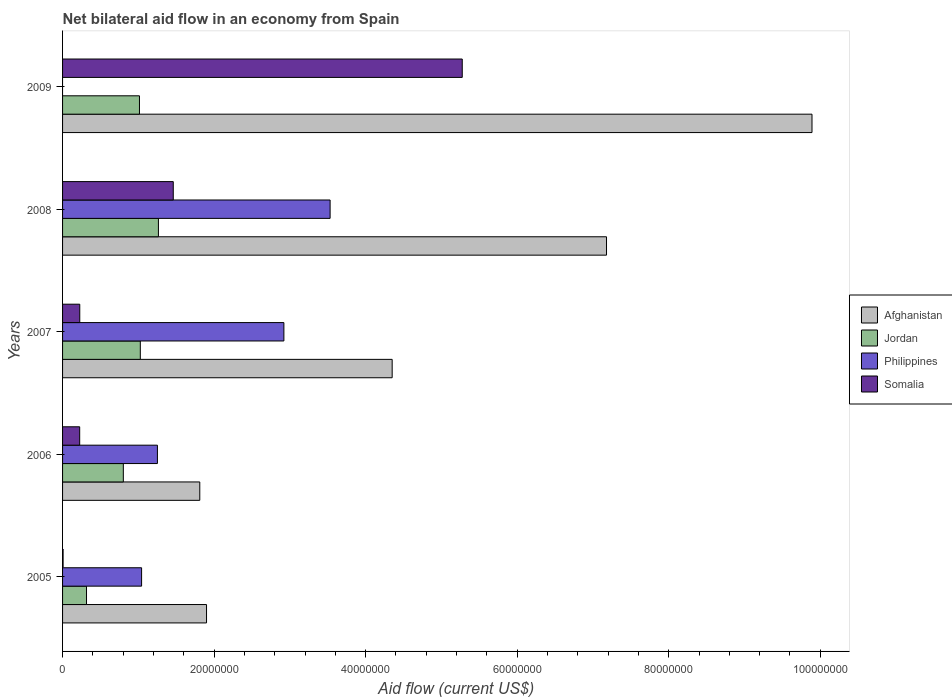Are the number of bars on each tick of the Y-axis equal?
Your response must be concise. No. What is the net bilateral aid flow in Jordan in 2006?
Provide a succinct answer. 8.02e+06. Across all years, what is the maximum net bilateral aid flow in Afghanistan?
Ensure brevity in your answer.  9.89e+07. In which year was the net bilateral aid flow in Philippines maximum?
Ensure brevity in your answer.  2008. What is the total net bilateral aid flow in Somalia in the graph?
Provide a short and direct response. 7.20e+07. What is the difference between the net bilateral aid flow in Somalia in 2006 and that in 2007?
Offer a terse response. -10000. What is the difference between the net bilateral aid flow in Afghanistan in 2009 and the net bilateral aid flow in Somalia in 2008?
Offer a very short reply. 8.43e+07. What is the average net bilateral aid flow in Jordan per year?
Your answer should be very brief. 8.85e+06. In the year 2006, what is the difference between the net bilateral aid flow in Jordan and net bilateral aid flow in Afghanistan?
Give a very brief answer. -1.01e+07. In how many years, is the net bilateral aid flow in Afghanistan greater than 24000000 US$?
Provide a short and direct response. 3. What is the ratio of the net bilateral aid flow in Somalia in 2005 to that in 2009?
Keep it short and to the point. 0. Is the net bilateral aid flow in Somalia in 2005 less than that in 2006?
Offer a very short reply. Yes. Is the difference between the net bilateral aid flow in Jordan in 2007 and 2008 greater than the difference between the net bilateral aid flow in Afghanistan in 2007 and 2008?
Your response must be concise. Yes. What is the difference between the highest and the second highest net bilateral aid flow in Jordan?
Keep it short and to the point. 2.39e+06. What is the difference between the highest and the lowest net bilateral aid flow in Somalia?
Your response must be concise. 5.27e+07. In how many years, is the net bilateral aid flow in Philippines greater than the average net bilateral aid flow in Philippines taken over all years?
Provide a succinct answer. 2. Is the sum of the net bilateral aid flow in Jordan in 2005 and 2007 greater than the maximum net bilateral aid flow in Afghanistan across all years?
Provide a short and direct response. No. Is it the case that in every year, the sum of the net bilateral aid flow in Jordan and net bilateral aid flow in Somalia is greater than the sum of net bilateral aid flow in Philippines and net bilateral aid flow in Afghanistan?
Give a very brief answer. No. How many years are there in the graph?
Keep it short and to the point. 5. What is the difference between two consecutive major ticks on the X-axis?
Make the answer very short. 2.00e+07. Are the values on the major ticks of X-axis written in scientific E-notation?
Offer a very short reply. No. Where does the legend appear in the graph?
Offer a terse response. Center right. How many legend labels are there?
Offer a terse response. 4. How are the legend labels stacked?
Provide a succinct answer. Vertical. What is the title of the graph?
Make the answer very short. Net bilateral aid flow in an economy from Spain. Does "Switzerland" appear as one of the legend labels in the graph?
Keep it short and to the point. No. What is the Aid flow (current US$) of Afghanistan in 2005?
Give a very brief answer. 1.90e+07. What is the Aid flow (current US$) in Jordan in 2005?
Ensure brevity in your answer.  3.16e+06. What is the Aid flow (current US$) in Philippines in 2005?
Your response must be concise. 1.04e+07. What is the Aid flow (current US$) in Somalia in 2005?
Your answer should be compact. 7.00e+04. What is the Aid flow (current US$) of Afghanistan in 2006?
Offer a very short reply. 1.81e+07. What is the Aid flow (current US$) in Jordan in 2006?
Your answer should be compact. 8.02e+06. What is the Aid flow (current US$) in Philippines in 2006?
Ensure brevity in your answer.  1.25e+07. What is the Aid flow (current US$) of Somalia in 2006?
Your answer should be compact. 2.26e+06. What is the Aid flow (current US$) in Afghanistan in 2007?
Offer a very short reply. 4.35e+07. What is the Aid flow (current US$) in Jordan in 2007?
Ensure brevity in your answer.  1.03e+07. What is the Aid flow (current US$) of Philippines in 2007?
Offer a very short reply. 2.92e+07. What is the Aid flow (current US$) of Somalia in 2007?
Provide a short and direct response. 2.27e+06. What is the Aid flow (current US$) of Afghanistan in 2008?
Provide a short and direct response. 7.18e+07. What is the Aid flow (current US$) in Jordan in 2008?
Your answer should be compact. 1.26e+07. What is the Aid flow (current US$) in Philippines in 2008?
Ensure brevity in your answer.  3.53e+07. What is the Aid flow (current US$) of Somalia in 2008?
Provide a short and direct response. 1.46e+07. What is the Aid flow (current US$) of Afghanistan in 2009?
Keep it short and to the point. 9.89e+07. What is the Aid flow (current US$) in Jordan in 2009?
Your response must be concise. 1.02e+07. What is the Aid flow (current US$) of Somalia in 2009?
Your response must be concise. 5.28e+07. Across all years, what is the maximum Aid flow (current US$) of Afghanistan?
Ensure brevity in your answer.  9.89e+07. Across all years, what is the maximum Aid flow (current US$) of Jordan?
Keep it short and to the point. 1.26e+07. Across all years, what is the maximum Aid flow (current US$) in Philippines?
Offer a very short reply. 3.53e+07. Across all years, what is the maximum Aid flow (current US$) in Somalia?
Make the answer very short. 5.28e+07. Across all years, what is the minimum Aid flow (current US$) of Afghanistan?
Offer a very short reply. 1.81e+07. Across all years, what is the minimum Aid flow (current US$) of Jordan?
Your response must be concise. 3.16e+06. What is the total Aid flow (current US$) of Afghanistan in the graph?
Your answer should be compact. 2.51e+08. What is the total Aid flow (current US$) in Jordan in the graph?
Provide a short and direct response. 4.42e+07. What is the total Aid flow (current US$) in Philippines in the graph?
Keep it short and to the point. 8.75e+07. What is the total Aid flow (current US$) in Somalia in the graph?
Give a very brief answer. 7.20e+07. What is the difference between the Aid flow (current US$) in Afghanistan in 2005 and that in 2006?
Provide a succinct answer. 8.90e+05. What is the difference between the Aid flow (current US$) in Jordan in 2005 and that in 2006?
Your response must be concise. -4.86e+06. What is the difference between the Aid flow (current US$) in Philippines in 2005 and that in 2006?
Your answer should be very brief. -2.09e+06. What is the difference between the Aid flow (current US$) of Somalia in 2005 and that in 2006?
Ensure brevity in your answer.  -2.19e+06. What is the difference between the Aid flow (current US$) in Afghanistan in 2005 and that in 2007?
Your answer should be very brief. -2.45e+07. What is the difference between the Aid flow (current US$) of Jordan in 2005 and that in 2007?
Your response must be concise. -7.10e+06. What is the difference between the Aid flow (current US$) in Philippines in 2005 and that in 2007?
Offer a very short reply. -1.88e+07. What is the difference between the Aid flow (current US$) of Somalia in 2005 and that in 2007?
Offer a terse response. -2.20e+06. What is the difference between the Aid flow (current US$) in Afghanistan in 2005 and that in 2008?
Give a very brief answer. -5.28e+07. What is the difference between the Aid flow (current US$) of Jordan in 2005 and that in 2008?
Provide a succinct answer. -9.49e+06. What is the difference between the Aid flow (current US$) in Philippines in 2005 and that in 2008?
Keep it short and to the point. -2.49e+07. What is the difference between the Aid flow (current US$) in Somalia in 2005 and that in 2008?
Your answer should be very brief. -1.45e+07. What is the difference between the Aid flow (current US$) in Afghanistan in 2005 and that in 2009?
Provide a short and direct response. -7.99e+07. What is the difference between the Aid flow (current US$) of Jordan in 2005 and that in 2009?
Your answer should be very brief. -6.99e+06. What is the difference between the Aid flow (current US$) of Somalia in 2005 and that in 2009?
Keep it short and to the point. -5.27e+07. What is the difference between the Aid flow (current US$) in Afghanistan in 2006 and that in 2007?
Offer a terse response. -2.54e+07. What is the difference between the Aid flow (current US$) of Jordan in 2006 and that in 2007?
Your response must be concise. -2.24e+06. What is the difference between the Aid flow (current US$) of Philippines in 2006 and that in 2007?
Keep it short and to the point. -1.67e+07. What is the difference between the Aid flow (current US$) in Somalia in 2006 and that in 2007?
Your answer should be very brief. -10000. What is the difference between the Aid flow (current US$) of Afghanistan in 2006 and that in 2008?
Your answer should be compact. -5.37e+07. What is the difference between the Aid flow (current US$) in Jordan in 2006 and that in 2008?
Provide a succinct answer. -4.63e+06. What is the difference between the Aid flow (current US$) in Philippines in 2006 and that in 2008?
Provide a short and direct response. -2.28e+07. What is the difference between the Aid flow (current US$) of Somalia in 2006 and that in 2008?
Offer a very short reply. -1.24e+07. What is the difference between the Aid flow (current US$) of Afghanistan in 2006 and that in 2009?
Offer a terse response. -8.08e+07. What is the difference between the Aid flow (current US$) of Jordan in 2006 and that in 2009?
Provide a short and direct response. -2.13e+06. What is the difference between the Aid flow (current US$) in Somalia in 2006 and that in 2009?
Give a very brief answer. -5.05e+07. What is the difference between the Aid flow (current US$) of Afghanistan in 2007 and that in 2008?
Your response must be concise. -2.83e+07. What is the difference between the Aid flow (current US$) in Jordan in 2007 and that in 2008?
Offer a very short reply. -2.39e+06. What is the difference between the Aid flow (current US$) of Philippines in 2007 and that in 2008?
Offer a terse response. -6.10e+06. What is the difference between the Aid flow (current US$) of Somalia in 2007 and that in 2008?
Give a very brief answer. -1.23e+07. What is the difference between the Aid flow (current US$) of Afghanistan in 2007 and that in 2009?
Your answer should be very brief. -5.54e+07. What is the difference between the Aid flow (current US$) in Jordan in 2007 and that in 2009?
Ensure brevity in your answer.  1.10e+05. What is the difference between the Aid flow (current US$) in Somalia in 2007 and that in 2009?
Your response must be concise. -5.05e+07. What is the difference between the Aid flow (current US$) of Afghanistan in 2008 and that in 2009?
Provide a succinct answer. -2.71e+07. What is the difference between the Aid flow (current US$) in Jordan in 2008 and that in 2009?
Provide a short and direct response. 2.50e+06. What is the difference between the Aid flow (current US$) in Somalia in 2008 and that in 2009?
Your response must be concise. -3.81e+07. What is the difference between the Aid flow (current US$) of Afghanistan in 2005 and the Aid flow (current US$) of Jordan in 2006?
Offer a very short reply. 1.10e+07. What is the difference between the Aid flow (current US$) in Afghanistan in 2005 and the Aid flow (current US$) in Philippines in 2006?
Your answer should be compact. 6.48e+06. What is the difference between the Aid flow (current US$) in Afghanistan in 2005 and the Aid flow (current US$) in Somalia in 2006?
Offer a terse response. 1.67e+07. What is the difference between the Aid flow (current US$) of Jordan in 2005 and the Aid flow (current US$) of Philippines in 2006?
Provide a succinct answer. -9.36e+06. What is the difference between the Aid flow (current US$) in Philippines in 2005 and the Aid flow (current US$) in Somalia in 2006?
Provide a short and direct response. 8.17e+06. What is the difference between the Aid flow (current US$) in Afghanistan in 2005 and the Aid flow (current US$) in Jordan in 2007?
Your answer should be very brief. 8.74e+06. What is the difference between the Aid flow (current US$) of Afghanistan in 2005 and the Aid flow (current US$) of Philippines in 2007?
Ensure brevity in your answer.  -1.02e+07. What is the difference between the Aid flow (current US$) in Afghanistan in 2005 and the Aid flow (current US$) in Somalia in 2007?
Keep it short and to the point. 1.67e+07. What is the difference between the Aid flow (current US$) in Jordan in 2005 and the Aid flow (current US$) in Philippines in 2007?
Your answer should be very brief. -2.60e+07. What is the difference between the Aid flow (current US$) in Jordan in 2005 and the Aid flow (current US$) in Somalia in 2007?
Make the answer very short. 8.90e+05. What is the difference between the Aid flow (current US$) in Philippines in 2005 and the Aid flow (current US$) in Somalia in 2007?
Your answer should be very brief. 8.16e+06. What is the difference between the Aid flow (current US$) of Afghanistan in 2005 and the Aid flow (current US$) of Jordan in 2008?
Your response must be concise. 6.35e+06. What is the difference between the Aid flow (current US$) of Afghanistan in 2005 and the Aid flow (current US$) of Philippines in 2008?
Give a very brief answer. -1.63e+07. What is the difference between the Aid flow (current US$) of Afghanistan in 2005 and the Aid flow (current US$) of Somalia in 2008?
Keep it short and to the point. 4.39e+06. What is the difference between the Aid flow (current US$) of Jordan in 2005 and the Aid flow (current US$) of Philippines in 2008?
Your response must be concise. -3.22e+07. What is the difference between the Aid flow (current US$) in Jordan in 2005 and the Aid flow (current US$) in Somalia in 2008?
Ensure brevity in your answer.  -1.14e+07. What is the difference between the Aid flow (current US$) of Philippines in 2005 and the Aid flow (current US$) of Somalia in 2008?
Your response must be concise. -4.18e+06. What is the difference between the Aid flow (current US$) in Afghanistan in 2005 and the Aid flow (current US$) in Jordan in 2009?
Your answer should be compact. 8.85e+06. What is the difference between the Aid flow (current US$) of Afghanistan in 2005 and the Aid flow (current US$) of Somalia in 2009?
Your answer should be very brief. -3.38e+07. What is the difference between the Aid flow (current US$) in Jordan in 2005 and the Aid flow (current US$) in Somalia in 2009?
Your answer should be compact. -4.96e+07. What is the difference between the Aid flow (current US$) in Philippines in 2005 and the Aid flow (current US$) in Somalia in 2009?
Provide a short and direct response. -4.23e+07. What is the difference between the Aid flow (current US$) of Afghanistan in 2006 and the Aid flow (current US$) of Jordan in 2007?
Provide a succinct answer. 7.85e+06. What is the difference between the Aid flow (current US$) of Afghanistan in 2006 and the Aid flow (current US$) of Philippines in 2007?
Provide a succinct answer. -1.11e+07. What is the difference between the Aid flow (current US$) in Afghanistan in 2006 and the Aid flow (current US$) in Somalia in 2007?
Make the answer very short. 1.58e+07. What is the difference between the Aid flow (current US$) of Jordan in 2006 and the Aid flow (current US$) of Philippines in 2007?
Offer a very short reply. -2.12e+07. What is the difference between the Aid flow (current US$) in Jordan in 2006 and the Aid flow (current US$) in Somalia in 2007?
Your answer should be compact. 5.75e+06. What is the difference between the Aid flow (current US$) of Philippines in 2006 and the Aid flow (current US$) of Somalia in 2007?
Provide a short and direct response. 1.02e+07. What is the difference between the Aid flow (current US$) of Afghanistan in 2006 and the Aid flow (current US$) of Jordan in 2008?
Ensure brevity in your answer.  5.46e+06. What is the difference between the Aid flow (current US$) in Afghanistan in 2006 and the Aid flow (current US$) in Philippines in 2008?
Offer a terse response. -1.72e+07. What is the difference between the Aid flow (current US$) of Afghanistan in 2006 and the Aid flow (current US$) of Somalia in 2008?
Your answer should be compact. 3.50e+06. What is the difference between the Aid flow (current US$) of Jordan in 2006 and the Aid flow (current US$) of Philippines in 2008?
Offer a very short reply. -2.73e+07. What is the difference between the Aid flow (current US$) of Jordan in 2006 and the Aid flow (current US$) of Somalia in 2008?
Provide a succinct answer. -6.59e+06. What is the difference between the Aid flow (current US$) in Philippines in 2006 and the Aid flow (current US$) in Somalia in 2008?
Your answer should be very brief. -2.09e+06. What is the difference between the Aid flow (current US$) in Afghanistan in 2006 and the Aid flow (current US$) in Jordan in 2009?
Provide a succinct answer. 7.96e+06. What is the difference between the Aid flow (current US$) in Afghanistan in 2006 and the Aid flow (current US$) in Somalia in 2009?
Make the answer very short. -3.46e+07. What is the difference between the Aid flow (current US$) in Jordan in 2006 and the Aid flow (current US$) in Somalia in 2009?
Your response must be concise. -4.47e+07. What is the difference between the Aid flow (current US$) of Philippines in 2006 and the Aid flow (current US$) of Somalia in 2009?
Make the answer very short. -4.02e+07. What is the difference between the Aid flow (current US$) in Afghanistan in 2007 and the Aid flow (current US$) in Jordan in 2008?
Provide a short and direct response. 3.08e+07. What is the difference between the Aid flow (current US$) in Afghanistan in 2007 and the Aid flow (current US$) in Philippines in 2008?
Offer a terse response. 8.19e+06. What is the difference between the Aid flow (current US$) in Afghanistan in 2007 and the Aid flow (current US$) in Somalia in 2008?
Your answer should be compact. 2.89e+07. What is the difference between the Aid flow (current US$) of Jordan in 2007 and the Aid flow (current US$) of Philippines in 2008?
Keep it short and to the point. -2.50e+07. What is the difference between the Aid flow (current US$) of Jordan in 2007 and the Aid flow (current US$) of Somalia in 2008?
Offer a terse response. -4.35e+06. What is the difference between the Aid flow (current US$) of Philippines in 2007 and the Aid flow (current US$) of Somalia in 2008?
Make the answer very short. 1.46e+07. What is the difference between the Aid flow (current US$) in Afghanistan in 2007 and the Aid flow (current US$) in Jordan in 2009?
Make the answer very short. 3.34e+07. What is the difference between the Aid flow (current US$) in Afghanistan in 2007 and the Aid flow (current US$) in Somalia in 2009?
Your answer should be very brief. -9.25e+06. What is the difference between the Aid flow (current US$) in Jordan in 2007 and the Aid flow (current US$) in Somalia in 2009?
Your answer should be very brief. -4.25e+07. What is the difference between the Aid flow (current US$) of Philippines in 2007 and the Aid flow (current US$) of Somalia in 2009?
Ensure brevity in your answer.  -2.35e+07. What is the difference between the Aid flow (current US$) of Afghanistan in 2008 and the Aid flow (current US$) of Jordan in 2009?
Offer a very short reply. 6.16e+07. What is the difference between the Aid flow (current US$) in Afghanistan in 2008 and the Aid flow (current US$) in Somalia in 2009?
Make the answer very short. 1.90e+07. What is the difference between the Aid flow (current US$) in Jordan in 2008 and the Aid flow (current US$) in Somalia in 2009?
Make the answer very short. -4.01e+07. What is the difference between the Aid flow (current US$) of Philippines in 2008 and the Aid flow (current US$) of Somalia in 2009?
Your answer should be compact. -1.74e+07. What is the average Aid flow (current US$) of Afghanistan per year?
Your answer should be very brief. 5.03e+07. What is the average Aid flow (current US$) in Jordan per year?
Your answer should be very brief. 8.85e+06. What is the average Aid flow (current US$) of Philippines per year?
Keep it short and to the point. 1.75e+07. What is the average Aid flow (current US$) in Somalia per year?
Your answer should be compact. 1.44e+07. In the year 2005, what is the difference between the Aid flow (current US$) of Afghanistan and Aid flow (current US$) of Jordan?
Keep it short and to the point. 1.58e+07. In the year 2005, what is the difference between the Aid flow (current US$) in Afghanistan and Aid flow (current US$) in Philippines?
Offer a very short reply. 8.57e+06. In the year 2005, what is the difference between the Aid flow (current US$) of Afghanistan and Aid flow (current US$) of Somalia?
Provide a short and direct response. 1.89e+07. In the year 2005, what is the difference between the Aid flow (current US$) of Jordan and Aid flow (current US$) of Philippines?
Your response must be concise. -7.27e+06. In the year 2005, what is the difference between the Aid flow (current US$) in Jordan and Aid flow (current US$) in Somalia?
Ensure brevity in your answer.  3.09e+06. In the year 2005, what is the difference between the Aid flow (current US$) of Philippines and Aid flow (current US$) of Somalia?
Offer a terse response. 1.04e+07. In the year 2006, what is the difference between the Aid flow (current US$) in Afghanistan and Aid flow (current US$) in Jordan?
Your answer should be very brief. 1.01e+07. In the year 2006, what is the difference between the Aid flow (current US$) of Afghanistan and Aid flow (current US$) of Philippines?
Ensure brevity in your answer.  5.59e+06. In the year 2006, what is the difference between the Aid flow (current US$) of Afghanistan and Aid flow (current US$) of Somalia?
Ensure brevity in your answer.  1.58e+07. In the year 2006, what is the difference between the Aid flow (current US$) of Jordan and Aid flow (current US$) of Philippines?
Your answer should be compact. -4.50e+06. In the year 2006, what is the difference between the Aid flow (current US$) of Jordan and Aid flow (current US$) of Somalia?
Make the answer very short. 5.76e+06. In the year 2006, what is the difference between the Aid flow (current US$) in Philippines and Aid flow (current US$) in Somalia?
Make the answer very short. 1.03e+07. In the year 2007, what is the difference between the Aid flow (current US$) of Afghanistan and Aid flow (current US$) of Jordan?
Make the answer very short. 3.32e+07. In the year 2007, what is the difference between the Aid flow (current US$) in Afghanistan and Aid flow (current US$) in Philippines?
Your response must be concise. 1.43e+07. In the year 2007, what is the difference between the Aid flow (current US$) of Afghanistan and Aid flow (current US$) of Somalia?
Your answer should be compact. 4.12e+07. In the year 2007, what is the difference between the Aid flow (current US$) in Jordan and Aid flow (current US$) in Philippines?
Ensure brevity in your answer.  -1.90e+07. In the year 2007, what is the difference between the Aid flow (current US$) in Jordan and Aid flow (current US$) in Somalia?
Your answer should be very brief. 7.99e+06. In the year 2007, what is the difference between the Aid flow (current US$) of Philippines and Aid flow (current US$) of Somalia?
Make the answer very short. 2.69e+07. In the year 2008, what is the difference between the Aid flow (current US$) of Afghanistan and Aid flow (current US$) of Jordan?
Provide a succinct answer. 5.91e+07. In the year 2008, what is the difference between the Aid flow (current US$) of Afghanistan and Aid flow (current US$) of Philippines?
Ensure brevity in your answer.  3.65e+07. In the year 2008, what is the difference between the Aid flow (current US$) of Afghanistan and Aid flow (current US$) of Somalia?
Your answer should be compact. 5.72e+07. In the year 2008, what is the difference between the Aid flow (current US$) in Jordan and Aid flow (current US$) in Philippines?
Offer a very short reply. -2.27e+07. In the year 2008, what is the difference between the Aid flow (current US$) of Jordan and Aid flow (current US$) of Somalia?
Offer a terse response. -1.96e+06. In the year 2008, what is the difference between the Aid flow (current US$) of Philippines and Aid flow (current US$) of Somalia?
Give a very brief answer. 2.07e+07. In the year 2009, what is the difference between the Aid flow (current US$) in Afghanistan and Aid flow (current US$) in Jordan?
Ensure brevity in your answer.  8.88e+07. In the year 2009, what is the difference between the Aid flow (current US$) in Afghanistan and Aid flow (current US$) in Somalia?
Your response must be concise. 4.62e+07. In the year 2009, what is the difference between the Aid flow (current US$) in Jordan and Aid flow (current US$) in Somalia?
Keep it short and to the point. -4.26e+07. What is the ratio of the Aid flow (current US$) of Afghanistan in 2005 to that in 2006?
Your answer should be very brief. 1.05. What is the ratio of the Aid flow (current US$) in Jordan in 2005 to that in 2006?
Your answer should be compact. 0.39. What is the ratio of the Aid flow (current US$) in Philippines in 2005 to that in 2006?
Provide a succinct answer. 0.83. What is the ratio of the Aid flow (current US$) in Somalia in 2005 to that in 2006?
Your answer should be very brief. 0.03. What is the ratio of the Aid flow (current US$) of Afghanistan in 2005 to that in 2007?
Offer a very short reply. 0.44. What is the ratio of the Aid flow (current US$) in Jordan in 2005 to that in 2007?
Provide a short and direct response. 0.31. What is the ratio of the Aid flow (current US$) of Philippines in 2005 to that in 2007?
Offer a terse response. 0.36. What is the ratio of the Aid flow (current US$) in Somalia in 2005 to that in 2007?
Keep it short and to the point. 0.03. What is the ratio of the Aid flow (current US$) in Afghanistan in 2005 to that in 2008?
Offer a very short reply. 0.26. What is the ratio of the Aid flow (current US$) of Jordan in 2005 to that in 2008?
Your answer should be compact. 0.25. What is the ratio of the Aid flow (current US$) of Philippines in 2005 to that in 2008?
Keep it short and to the point. 0.3. What is the ratio of the Aid flow (current US$) in Somalia in 2005 to that in 2008?
Give a very brief answer. 0. What is the ratio of the Aid flow (current US$) of Afghanistan in 2005 to that in 2009?
Keep it short and to the point. 0.19. What is the ratio of the Aid flow (current US$) of Jordan in 2005 to that in 2009?
Ensure brevity in your answer.  0.31. What is the ratio of the Aid flow (current US$) in Somalia in 2005 to that in 2009?
Your answer should be very brief. 0. What is the ratio of the Aid flow (current US$) of Afghanistan in 2006 to that in 2007?
Ensure brevity in your answer.  0.42. What is the ratio of the Aid flow (current US$) of Jordan in 2006 to that in 2007?
Your response must be concise. 0.78. What is the ratio of the Aid flow (current US$) in Philippines in 2006 to that in 2007?
Ensure brevity in your answer.  0.43. What is the ratio of the Aid flow (current US$) of Somalia in 2006 to that in 2007?
Give a very brief answer. 1. What is the ratio of the Aid flow (current US$) in Afghanistan in 2006 to that in 2008?
Offer a very short reply. 0.25. What is the ratio of the Aid flow (current US$) of Jordan in 2006 to that in 2008?
Ensure brevity in your answer.  0.63. What is the ratio of the Aid flow (current US$) of Philippines in 2006 to that in 2008?
Give a very brief answer. 0.35. What is the ratio of the Aid flow (current US$) of Somalia in 2006 to that in 2008?
Ensure brevity in your answer.  0.15. What is the ratio of the Aid flow (current US$) in Afghanistan in 2006 to that in 2009?
Give a very brief answer. 0.18. What is the ratio of the Aid flow (current US$) in Jordan in 2006 to that in 2009?
Ensure brevity in your answer.  0.79. What is the ratio of the Aid flow (current US$) of Somalia in 2006 to that in 2009?
Keep it short and to the point. 0.04. What is the ratio of the Aid flow (current US$) of Afghanistan in 2007 to that in 2008?
Your answer should be very brief. 0.61. What is the ratio of the Aid flow (current US$) in Jordan in 2007 to that in 2008?
Your answer should be very brief. 0.81. What is the ratio of the Aid flow (current US$) of Philippines in 2007 to that in 2008?
Give a very brief answer. 0.83. What is the ratio of the Aid flow (current US$) of Somalia in 2007 to that in 2008?
Provide a short and direct response. 0.16. What is the ratio of the Aid flow (current US$) in Afghanistan in 2007 to that in 2009?
Ensure brevity in your answer.  0.44. What is the ratio of the Aid flow (current US$) in Jordan in 2007 to that in 2009?
Give a very brief answer. 1.01. What is the ratio of the Aid flow (current US$) in Somalia in 2007 to that in 2009?
Make the answer very short. 0.04. What is the ratio of the Aid flow (current US$) in Afghanistan in 2008 to that in 2009?
Keep it short and to the point. 0.73. What is the ratio of the Aid flow (current US$) of Jordan in 2008 to that in 2009?
Your response must be concise. 1.25. What is the ratio of the Aid flow (current US$) of Somalia in 2008 to that in 2009?
Keep it short and to the point. 0.28. What is the difference between the highest and the second highest Aid flow (current US$) in Afghanistan?
Provide a succinct answer. 2.71e+07. What is the difference between the highest and the second highest Aid flow (current US$) in Jordan?
Offer a terse response. 2.39e+06. What is the difference between the highest and the second highest Aid flow (current US$) of Philippines?
Your answer should be very brief. 6.10e+06. What is the difference between the highest and the second highest Aid flow (current US$) in Somalia?
Offer a terse response. 3.81e+07. What is the difference between the highest and the lowest Aid flow (current US$) in Afghanistan?
Offer a terse response. 8.08e+07. What is the difference between the highest and the lowest Aid flow (current US$) of Jordan?
Your response must be concise. 9.49e+06. What is the difference between the highest and the lowest Aid flow (current US$) in Philippines?
Keep it short and to the point. 3.53e+07. What is the difference between the highest and the lowest Aid flow (current US$) in Somalia?
Your response must be concise. 5.27e+07. 